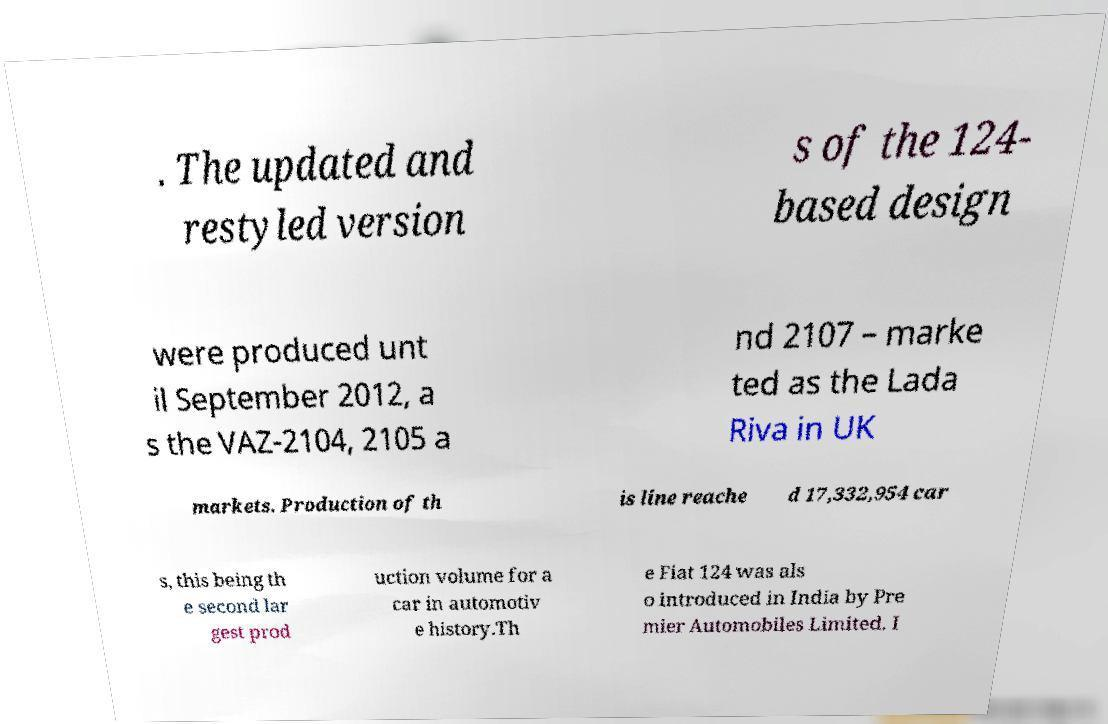Please identify and transcribe the text found in this image. . The updated and restyled version s of the 124- based design were produced unt il September 2012, a s the VAZ-2104, 2105 a nd 2107 – marke ted as the Lada Riva in UK markets. Production of th is line reache d 17,332,954 car s, this being th e second lar gest prod uction volume for a car in automotiv e history.Th e Fiat 124 was als o introduced in India by Pre mier Automobiles Limited. I 